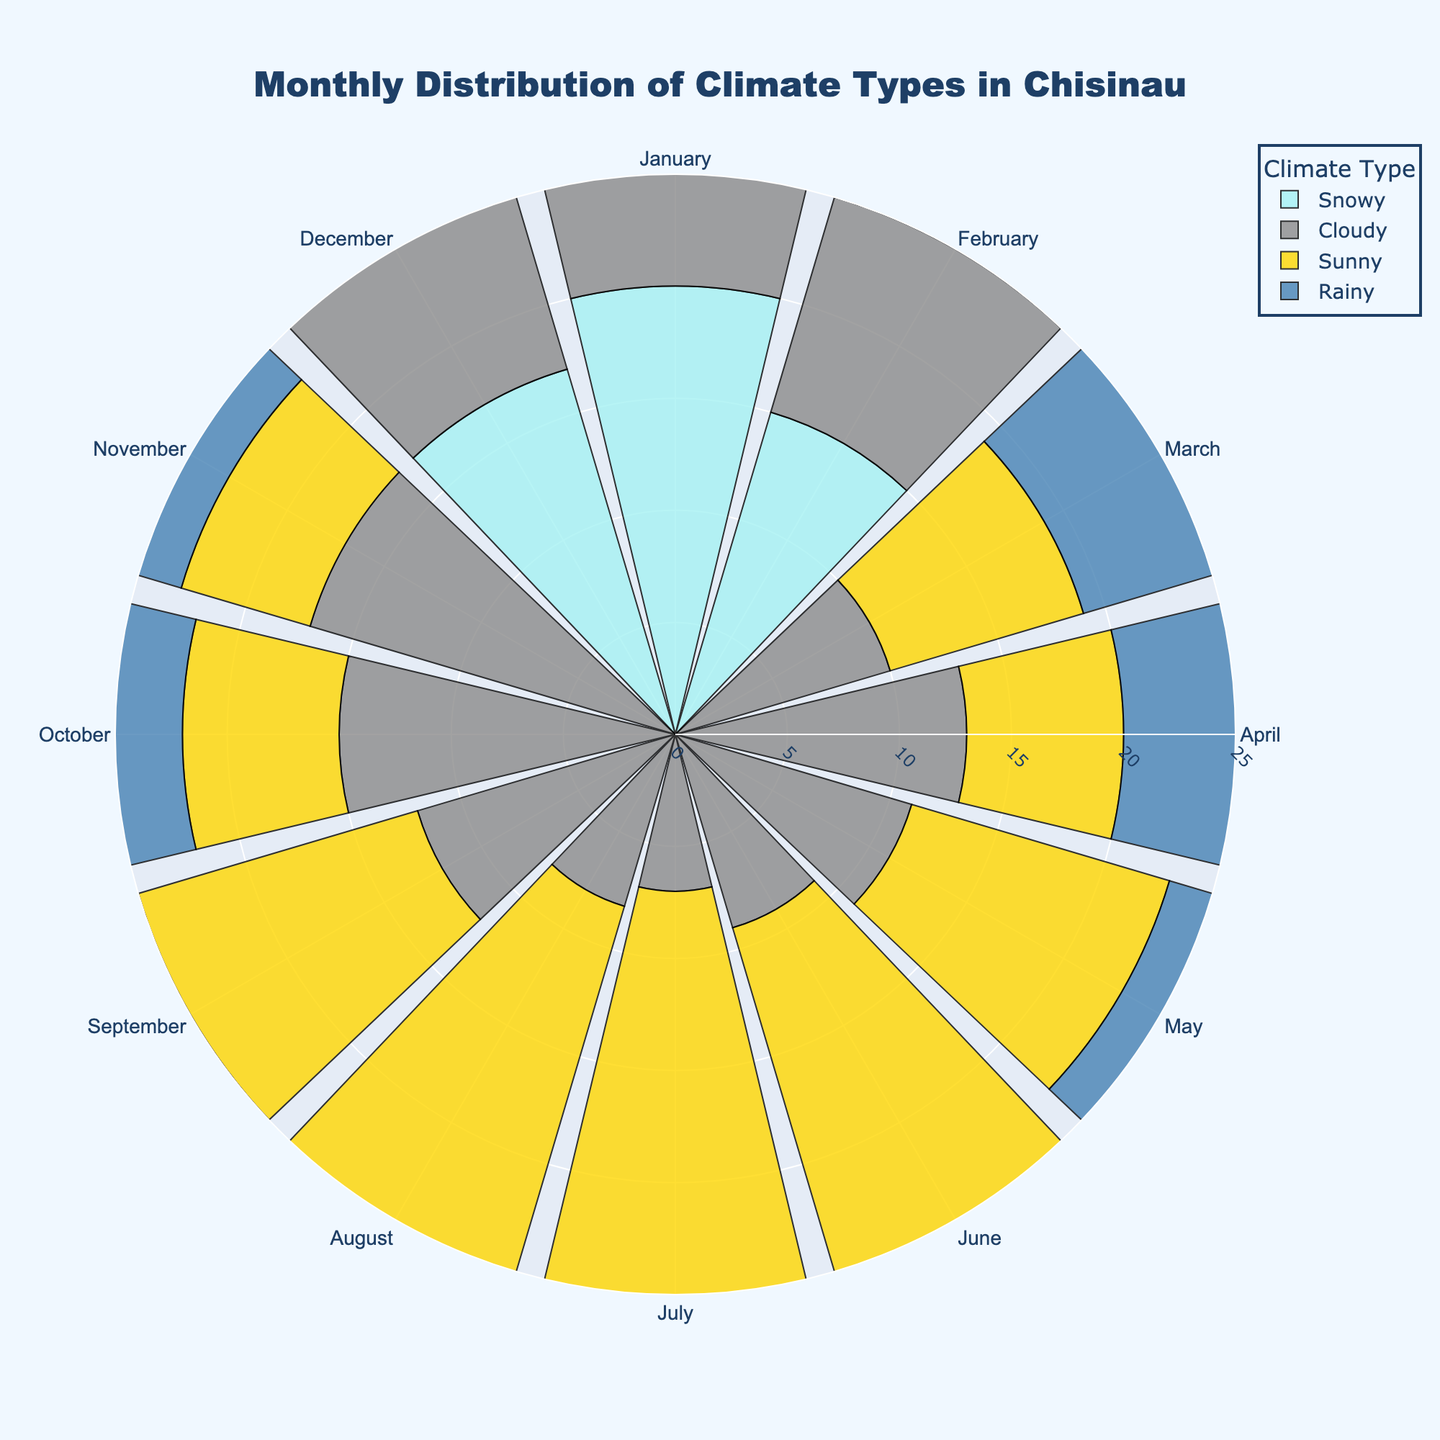What's the most common climate type in January? In the rose chart, locate the climate types for January. Snowy has the highest frequency with 20 observations.
Answer: Snowy How many days are sunny in July? Look at the segment corresponding to July. The frequency for Sunny is 20.
Answer: 20 Which month has the highest number of cloudy days? Look at all months and compare the frequencies for Cloudy. November has the highest with 17.
Answer: November What's the total number of snowy days in winter (January, February, December)? Sum up the frequencies of Snowy in January (20), February (15), and December (17). Total: 20 + 15 + 17 = 52.
Answer: 52 Is there any month without snowy days? Scan through each month's snowy frequency. No months show zero snowy days.
Answer: No How do the number of rainy days in March and May compare? Observe March (12) and May (8) for Rainy. March has more rainy days than May.
Answer: March has more What is the range of frequencies for sunny days across the months? Identify minimum and maximum frequencies of Sunny. Minimum is 3 (February), maximum is 20 (July). Range: 20 - 3 = 17.
Answer: 17 Which month has the least amount of rainy days? Find the lowest frequency value for Rainy. June has only 3 rainy days.
Answer: June How does July's sunny frequency compare to August's? Check July (20) and August (19) for Sunny. July has slightly more sunny days than August.
Answer: July has more What's the total frequency for all climate types in April? Add frequencies in April: Rainy (10) + Cloudy (13) + Sunny (7). Total: 10 + 13 + 7 = 30.
Answer: 30 